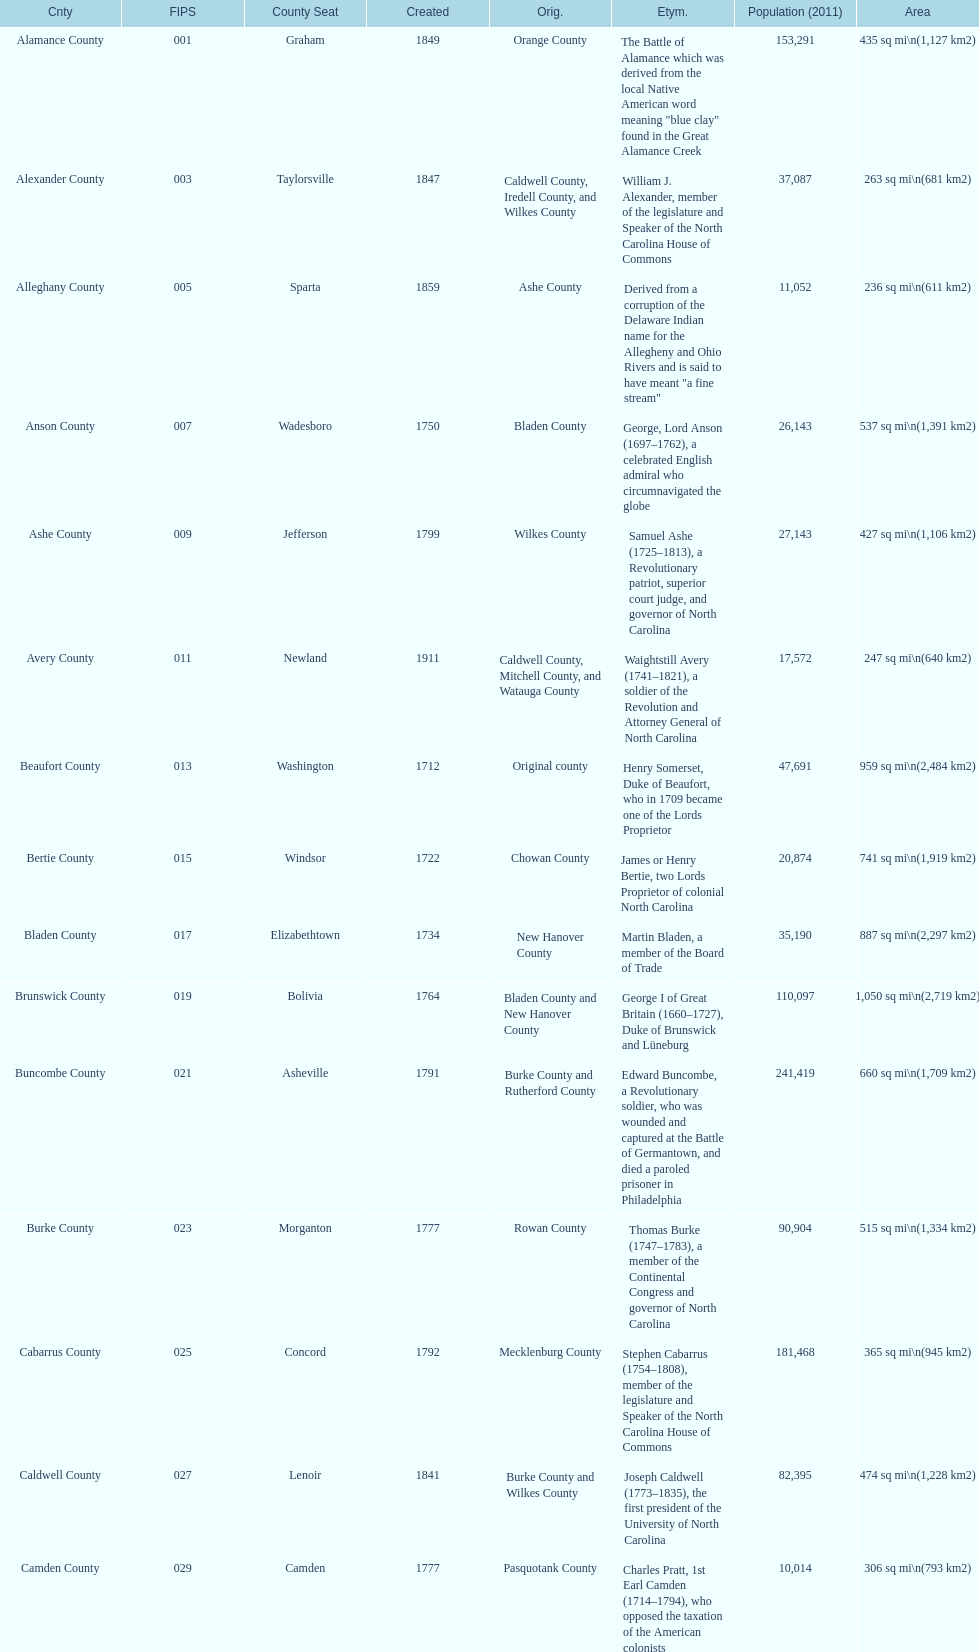What is the total number of counties listed? 100. 